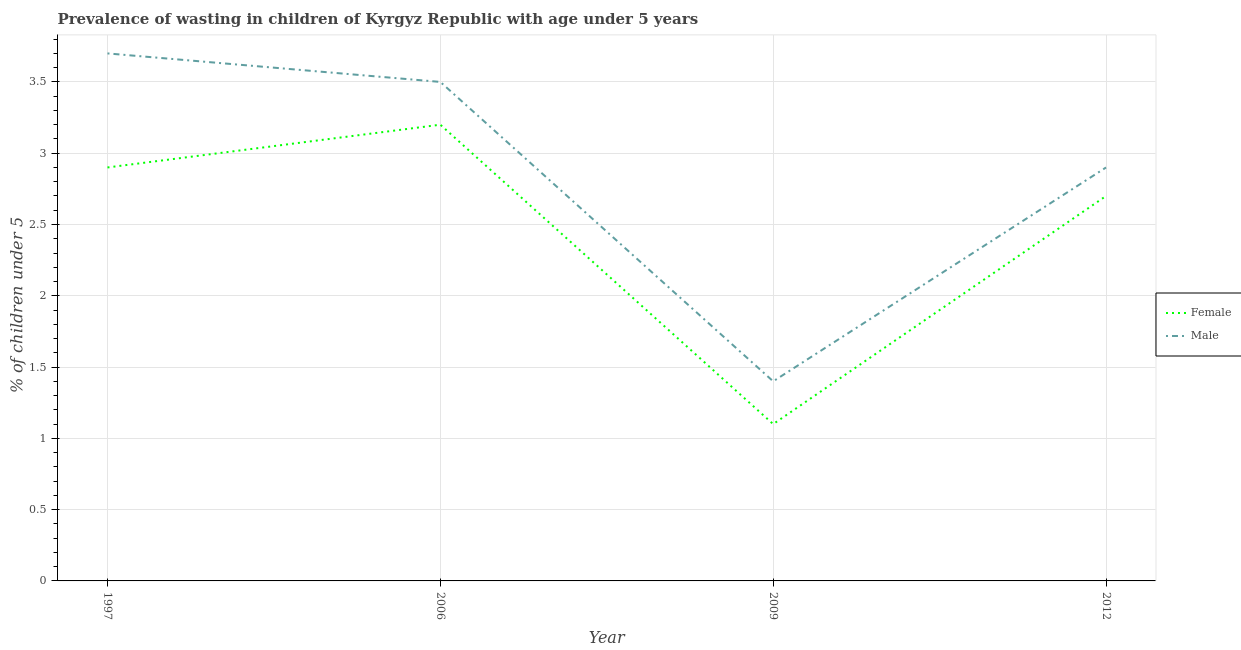Does the line corresponding to percentage of undernourished female children intersect with the line corresponding to percentage of undernourished male children?
Your answer should be very brief. No. Is the number of lines equal to the number of legend labels?
Keep it short and to the point. Yes. What is the percentage of undernourished male children in 2012?
Your answer should be compact. 2.9. Across all years, what is the maximum percentage of undernourished female children?
Provide a short and direct response. 3.2. Across all years, what is the minimum percentage of undernourished female children?
Provide a succinct answer. 1.1. In which year was the percentage of undernourished female children maximum?
Make the answer very short. 2006. What is the total percentage of undernourished male children in the graph?
Give a very brief answer. 11.5. What is the difference between the percentage of undernourished male children in 2006 and that in 2012?
Provide a succinct answer. 0.6. What is the difference between the percentage of undernourished male children in 2006 and the percentage of undernourished female children in 1997?
Provide a succinct answer. 0.6. What is the average percentage of undernourished female children per year?
Offer a very short reply. 2.48. In the year 2006, what is the difference between the percentage of undernourished female children and percentage of undernourished male children?
Ensure brevity in your answer.  -0.3. In how many years, is the percentage of undernourished male children greater than 0.7 %?
Your response must be concise. 4. What is the ratio of the percentage of undernourished male children in 1997 to that in 2006?
Give a very brief answer. 1.06. Is the percentage of undernourished female children in 1997 less than that in 2006?
Your answer should be very brief. Yes. What is the difference between the highest and the second highest percentage of undernourished female children?
Your response must be concise. 0.3. What is the difference between the highest and the lowest percentage of undernourished male children?
Give a very brief answer. 2.3. In how many years, is the percentage of undernourished male children greater than the average percentage of undernourished male children taken over all years?
Ensure brevity in your answer.  3. Does the percentage of undernourished male children monotonically increase over the years?
Make the answer very short. No. Is the percentage of undernourished female children strictly greater than the percentage of undernourished male children over the years?
Make the answer very short. No. How many lines are there?
Give a very brief answer. 2. Does the graph contain grids?
Provide a succinct answer. Yes. How are the legend labels stacked?
Make the answer very short. Vertical. What is the title of the graph?
Your response must be concise. Prevalence of wasting in children of Kyrgyz Republic with age under 5 years. What is the label or title of the Y-axis?
Offer a very short reply.  % of children under 5. What is the  % of children under 5 in Female in 1997?
Your answer should be very brief. 2.9. What is the  % of children under 5 of Male in 1997?
Keep it short and to the point. 3.7. What is the  % of children under 5 of Female in 2006?
Make the answer very short. 3.2. What is the  % of children under 5 of Male in 2006?
Provide a succinct answer. 3.5. What is the  % of children under 5 of Female in 2009?
Give a very brief answer. 1.1. What is the  % of children under 5 in Male in 2009?
Provide a succinct answer. 1.4. What is the  % of children under 5 in Female in 2012?
Provide a succinct answer. 2.7. What is the  % of children under 5 in Male in 2012?
Provide a short and direct response. 2.9. Across all years, what is the maximum  % of children under 5 of Female?
Give a very brief answer. 3.2. Across all years, what is the maximum  % of children under 5 of Male?
Your answer should be compact. 3.7. Across all years, what is the minimum  % of children under 5 of Female?
Your answer should be compact. 1.1. Across all years, what is the minimum  % of children under 5 of Male?
Your answer should be compact. 1.4. What is the difference between the  % of children under 5 in Female in 1997 and that in 2009?
Give a very brief answer. 1.8. What is the difference between the  % of children under 5 in Male in 1997 and that in 2009?
Ensure brevity in your answer.  2.3. What is the difference between the  % of children under 5 in Female in 1997 and that in 2012?
Make the answer very short. 0.2. What is the difference between the  % of children under 5 in Male in 1997 and that in 2012?
Ensure brevity in your answer.  0.8. What is the difference between the  % of children under 5 of Female in 2006 and that in 2012?
Offer a terse response. 0.5. What is the difference between the  % of children under 5 of Female in 2009 and that in 2012?
Offer a very short reply. -1.6. What is the difference between the  % of children under 5 in Female in 2006 and the  % of children under 5 in Male in 2012?
Provide a succinct answer. 0.3. What is the average  % of children under 5 of Female per year?
Offer a very short reply. 2.48. What is the average  % of children under 5 in Male per year?
Your response must be concise. 2.88. In the year 1997, what is the difference between the  % of children under 5 of Female and  % of children under 5 of Male?
Offer a very short reply. -0.8. What is the ratio of the  % of children under 5 of Female in 1997 to that in 2006?
Your answer should be compact. 0.91. What is the ratio of the  % of children under 5 in Male in 1997 to that in 2006?
Your answer should be very brief. 1.06. What is the ratio of the  % of children under 5 in Female in 1997 to that in 2009?
Offer a very short reply. 2.64. What is the ratio of the  % of children under 5 of Male in 1997 to that in 2009?
Offer a terse response. 2.64. What is the ratio of the  % of children under 5 of Female in 1997 to that in 2012?
Offer a very short reply. 1.07. What is the ratio of the  % of children under 5 in Male in 1997 to that in 2012?
Offer a very short reply. 1.28. What is the ratio of the  % of children under 5 of Female in 2006 to that in 2009?
Your answer should be very brief. 2.91. What is the ratio of the  % of children under 5 in Male in 2006 to that in 2009?
Make the answer very short. 2.5. What is the ratio of the  % of children under 5 in Female in 2006 to that in 2012?
Give a very brief answer. 1.19. What is the ratio of the  % of children under 5 in Male in 2006 to that in 2012?
Your answer should be compact. 1.21. What is the ratio of the  % of children under 5 in Female in 2009 to that in 2012?
Your answer should be compact. 0.41. What is the ratio of the  % of children under 5 in Male in 2009 to that in 2012?
Your answer should be very brief. 0.48. What is the difference between the highest and the lowest  % of children under 5 of Female?
Make the answer very short. 2.1. What is the difference between the highest and the lowest  % of children under 5 of Male?
Your response must be concise. 2.3. 